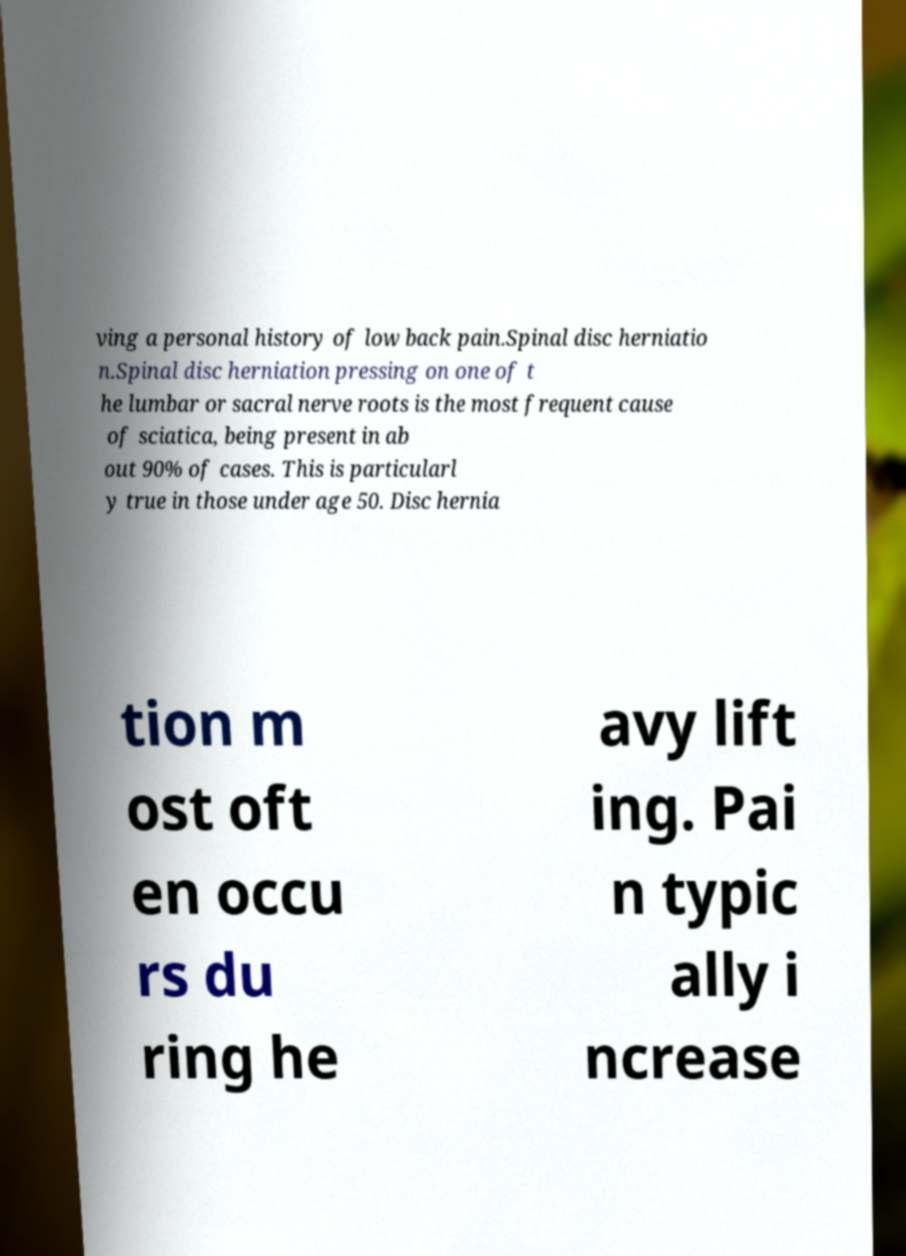Can you accurately transcribe the text from the provided image for me? ving a personal history of low back pain.Spinal disc herniatio n.Spinal disc herniation pressing on one of t he lumbar or sacral nerve roots is the most frequent cause of sciatica, being present in ab out 90% of cases. This is particularl y true in those under age 50. Disc hernia tion m ost oft en occu rs du ring he avy lift ing. Pai n typic ally i ncrease 